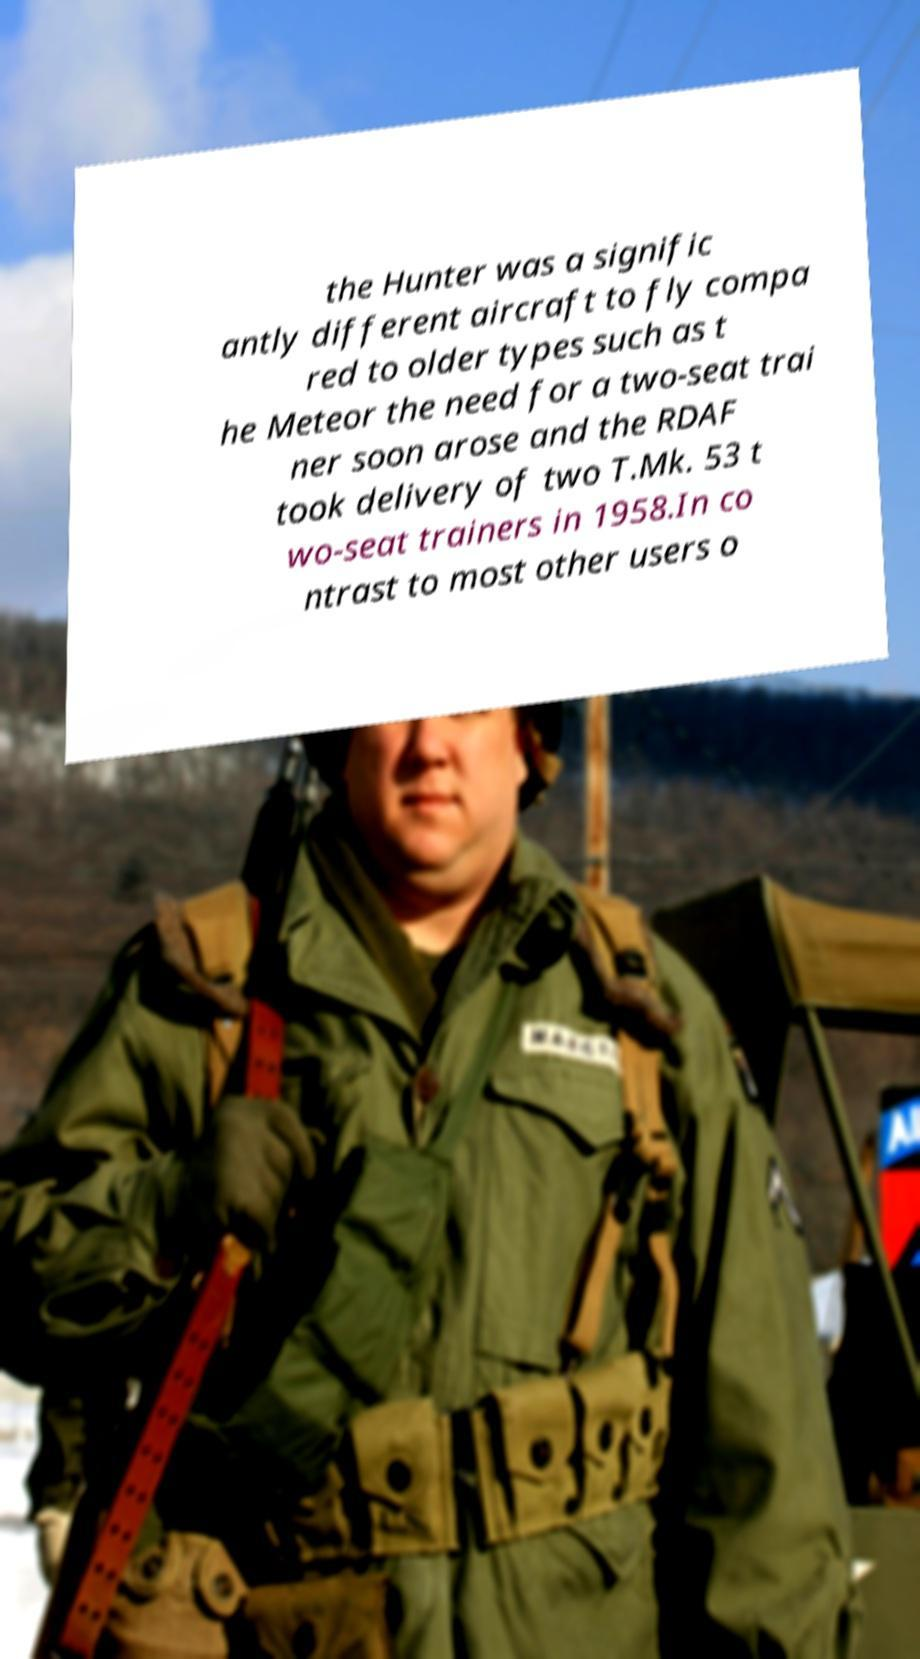Could you assist in decoding the text presented in this image and type it out clearly? the Hunter was a signific antly different aircraft to fly compa red to older types such as t he Meteor the need for a two-seat trai ner soon arose and the RDAF took delivery of two T.Mk. 53 t wo-seat trainers in 1958.In co ntrast to most other users o 